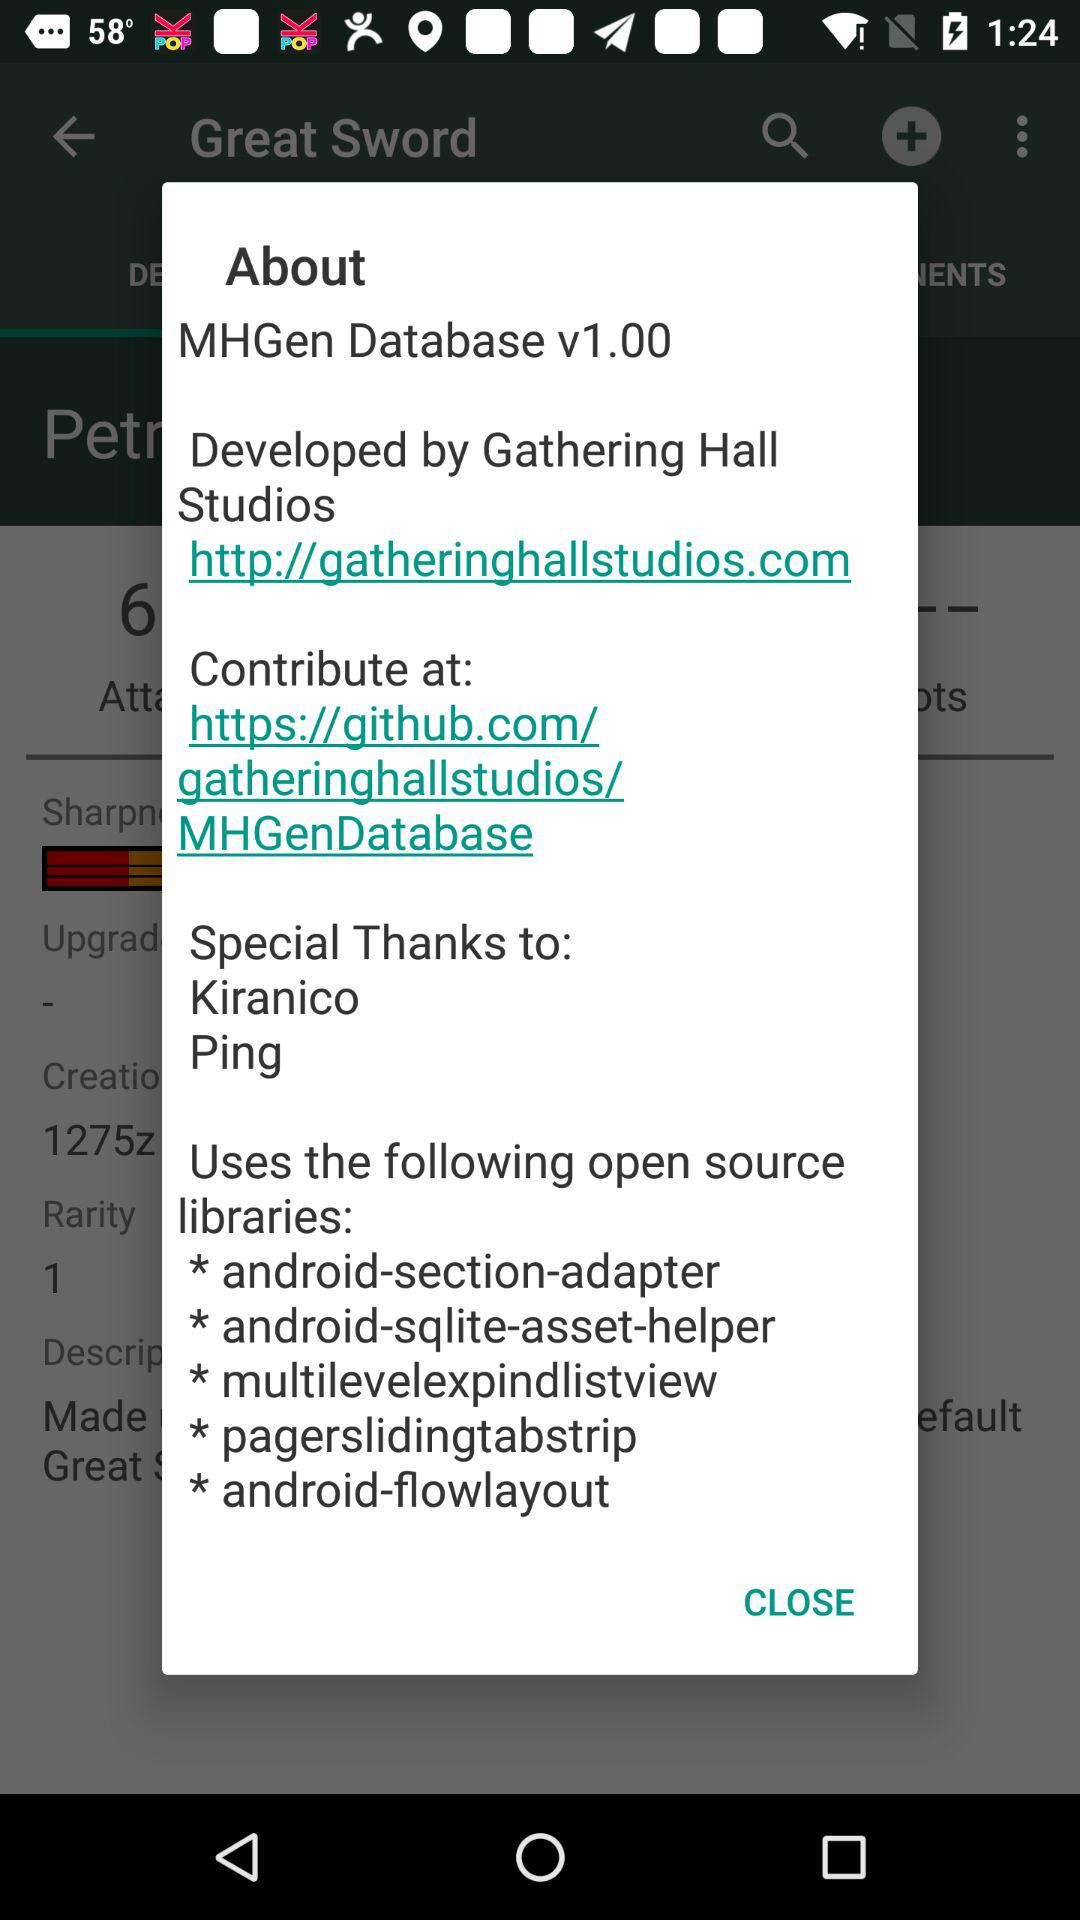Who is the developer? The developer is Gathering Hall Studios. 